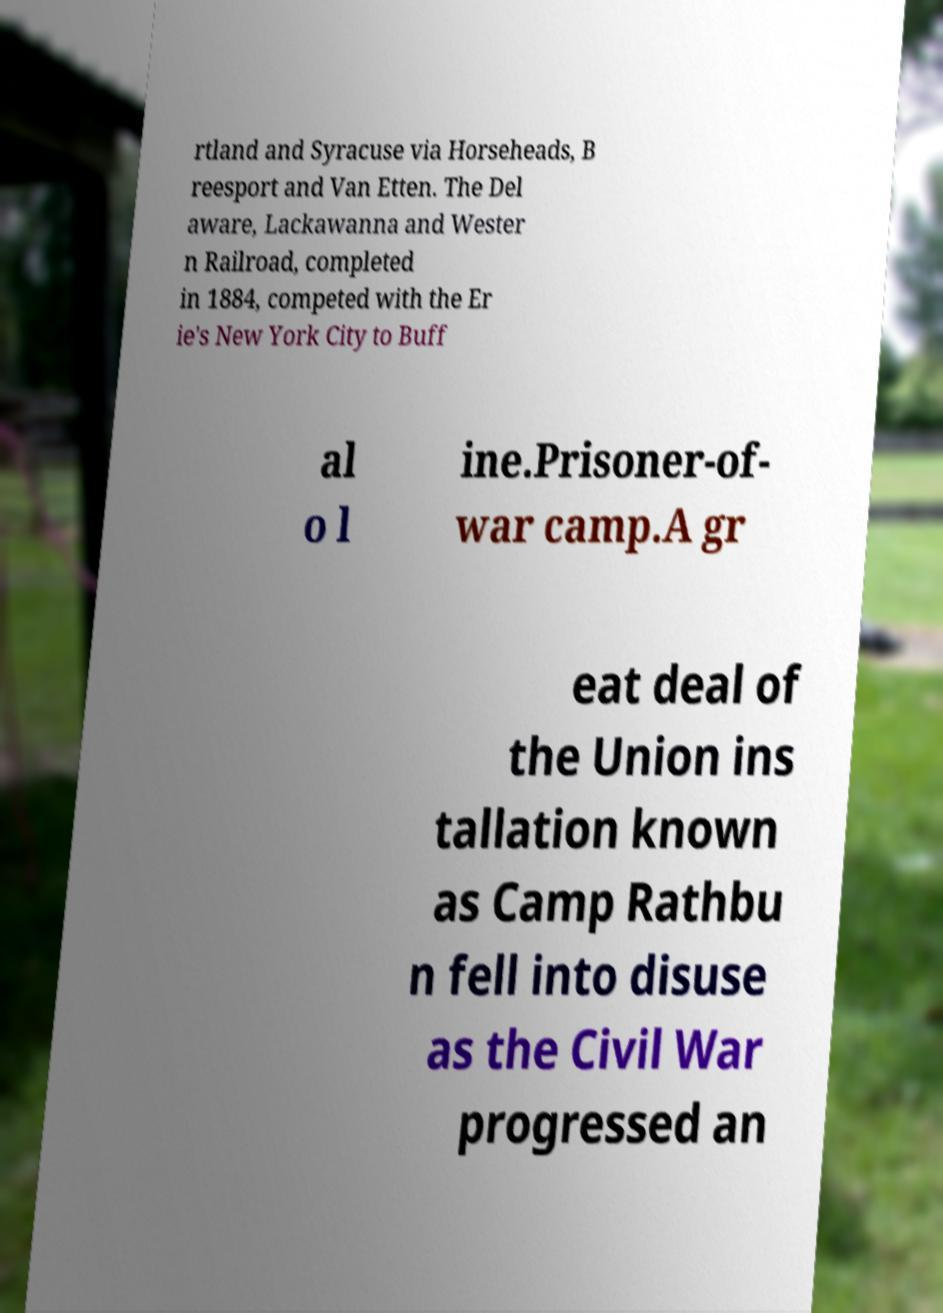Could you extract and type out the text from this image? rtland and Syracuse via Horseheads, B reesport and Van Etten. The Del aware, Lackawanna and Wester n Railroad, completed in 1884, competed with the Er ie's New York City to Buff al o l ine.Prisoner-of- war camp.A gr eat deal of the Union ins tallation known as Camp Rathbu n fell into disuse as the Civil War progressed an 